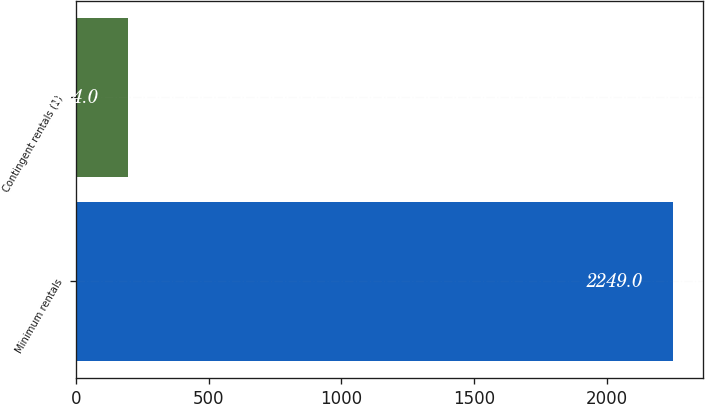Convert chart to OTSL. <chart><loc_0><loc_0><loc_500><loc_500><bar_chart><fcel>Minimum rentals<fcel>Contingent rentals (1)<nl><fcel>2249<fcel>194<nl></chart> 